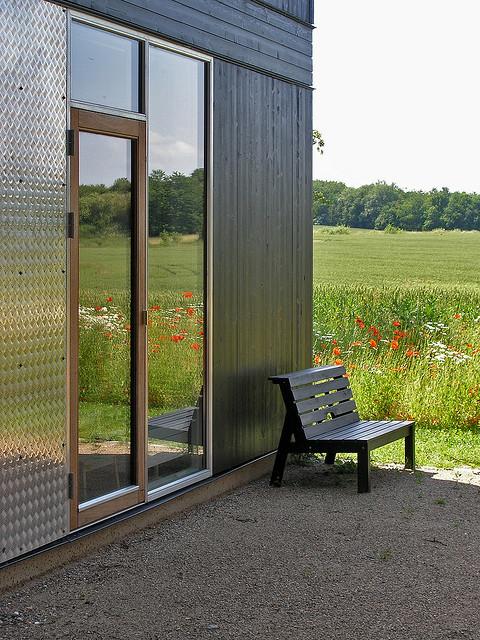Is anyone sitting on the bench?
Give a very brief answer. No. What color is the house?
Short answer required. Gray. What kind of metal is beside the door?
Write a very short answer. Aluminum. 